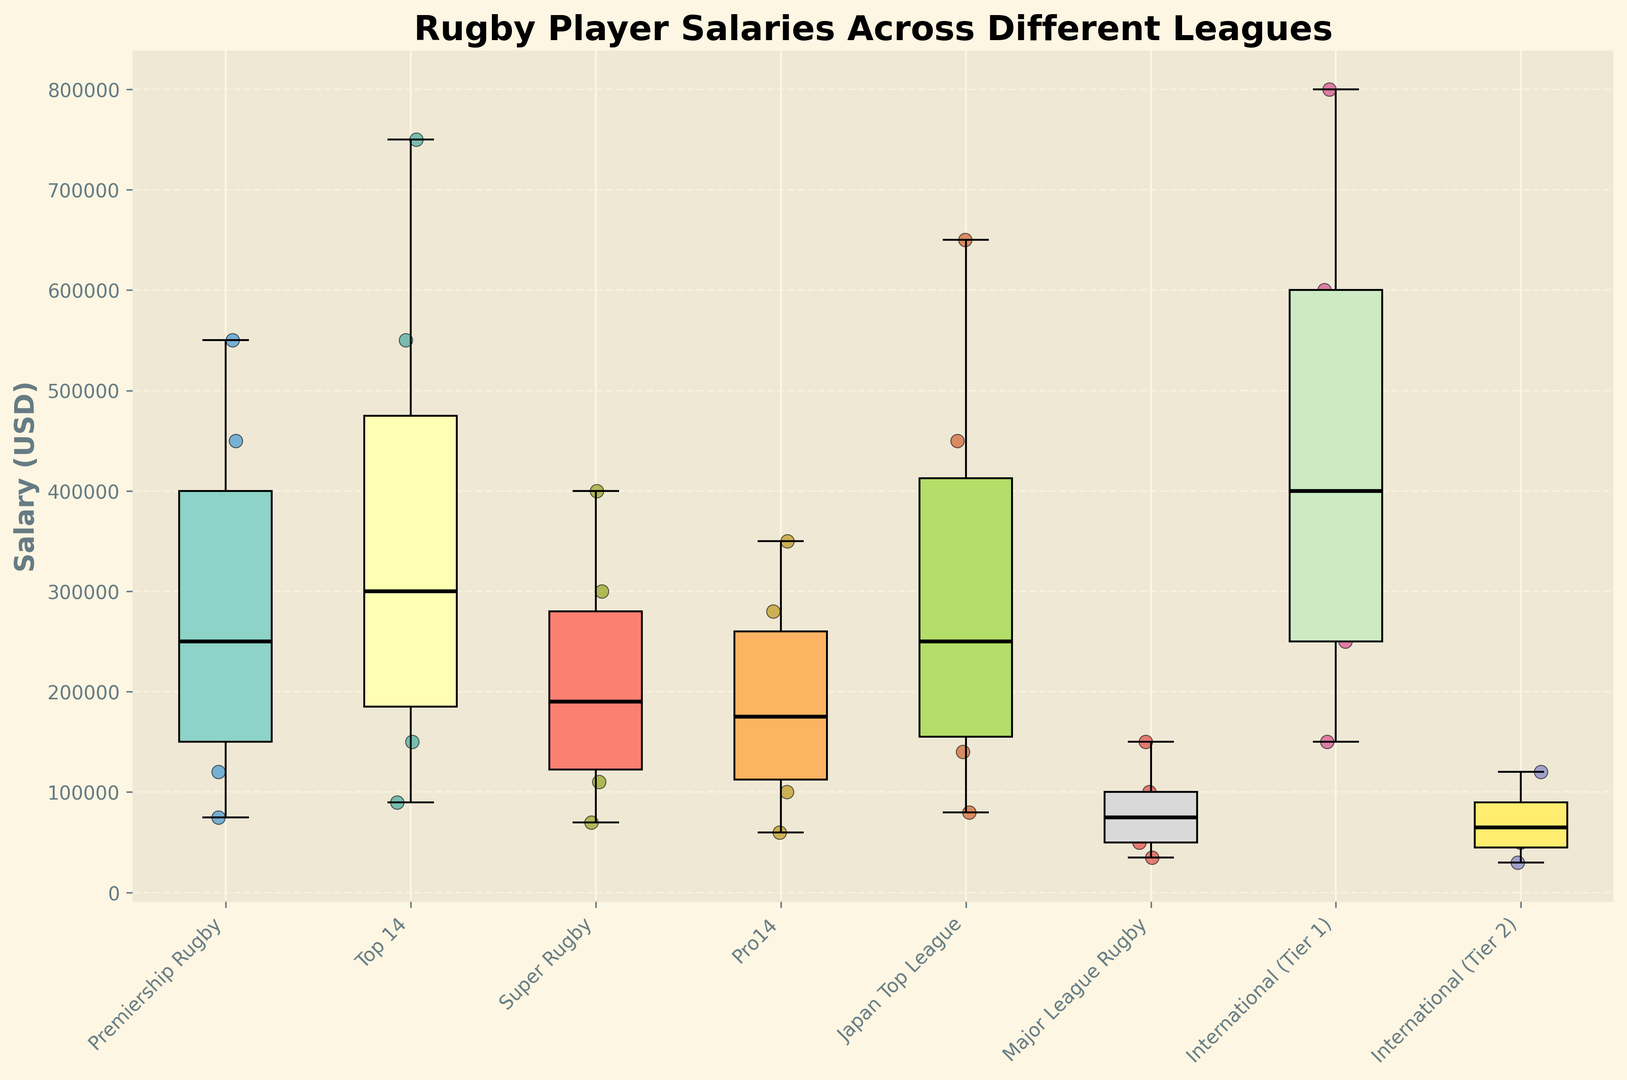What's the median salary of the Top 14 league? By observing the box plot, the median is represented by the bold line inside the box for the Top 14 league.
Answer: 300000 Which league has the highest maximum salary? The maximum salary is indicated by the topmost whisker in each box plot. The Top 14 league has the highest maximum salary, which is higher than other leagues.
Answer: Top 14 What is the interquartile range (IQR) of salaries in the Pro14 league? The IQR is the difference between the third quartile (Q3) and the first quartile (Q1). Observing the box for the Pro14 league, Q3 is at 280000 and Q1 is at 100000. Thus, IQR = Q3 - Q1 = 280000 - 100000.
Answer: 180000 Compare the median salaries of Super Rugby and Premiership Rugby. Which is higher? The median is the bold line within each box. By comparing the medians visually, Super Rugby has a lower median than Premiership Rugby.
Answer: Premiership Rugby How do the salary distributions of Major League Rugby and International (Tier 2) compare? Major League Rugby has a lower overall distribution with most salaries clustered below 150000, while International (Tier 2) shows a similar range but with some slightly higher values closer to and around 120000.
Answer: Major League Rugby has a lower distribution Which league appears to offer the most consistent salaries with the smallest range? Consistency can be inferred from the smallest spread between the minimum and maximum whiskers, and a closely packed box. Major League Rugby displays a narrower range, indicating consistency in salaries.
Answer: Major League Rugby Is there any overlap in salary ranges between Japan Top League and International (Tier 1)? By observing the whiskers, both box plots have overlapping ranges, indicating some salaries in the Japan Top League match those in International (Tier 1).
Answer: Yes What is the range of salaries in Premiership Rugby? The range is the difference between the maximum and minimum salaries. Observing the whiskers for Premiership Rugby, the maximum is 550000 and the minimum is 75000. So, Range = 550000 - 75000.
Answer: 475000 